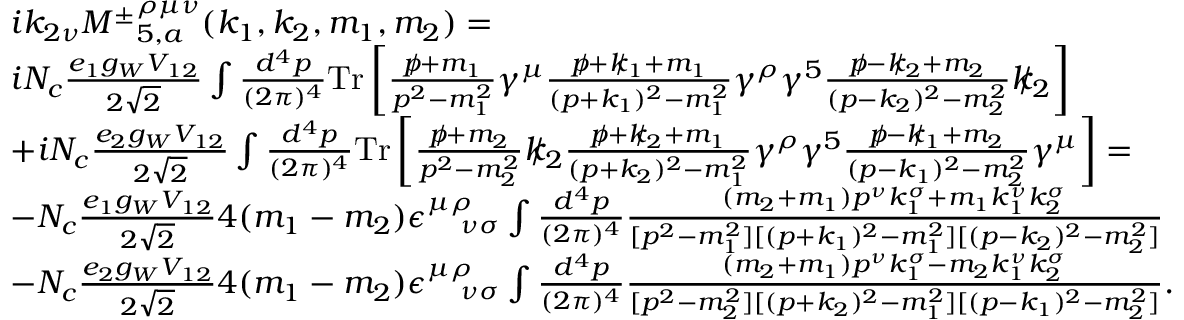Convert formula to latex. <formula><loc_0><loc_0><loc_500><loc_500>\begin{array} { r l } & { i k _ { 2 \nu } { M ^ { \pm } } _ { 5 , a } ^ { \rho \mu \nu } ( k _ { 1 } , k _ { 2 } , m _ { 1 } , m _ { 2 } ) = } \\ & { i N _ { c } \frac { e _ { 1 } g _ { W } V _ { 1 2 } } { 2 \sqrt { 2 } } \int \frac { d ^ { 4 } p } { ( 2 \pi ) ^ { 4 } } { T r } \left [ \frac { p \, / + m _ { 1 } } { p ^ { 2 } - m _ { 1 } ^ { 2 } } \gamma ^ { \mu } \frac { p \, / + k \, / _ { 1 } + m _ { 1 } } { ( p + k _ { 1 } ) ^ { 2 } - m _ { 1 } ^ { 2 } } \gamma ^ { \rho } \gamma ^ { 5 } \frac { p \, / - k \, / _ { 2 } + m _ { 2 } } { ( p - k _ { 2 } ) ^ { 2 } - m _ { 2 } ^ { 2 } } k \, / _ { 2 } \right ] } \\ & { + i N _ { c } \frac { e _ { 2 } g _ { W } V _ { 1 2 } } { 2 \sqrt { 2 } } \int \frac { d ^ { 4 } p } { ( 2 \pi ) ^ { 4 } } { T r } \left [ \frac { p \, / + m _ { 2 } } { p ^ { 2 } - m _ { 2 } ^ { 2 } } k \, / _ { 2 } \frac { p \, / + k \, / _ { 2 } + m _ { 1 } } { ( p + k _ { 2 } ) ^ { 2 } - m _ { 1 } ^ { 2 } } \gamma ^ { \rho } \gamma ^ { 5 } \frac { p \, / - k \, / _ { 1 } + m _ { 2 } } { ( p - k _ { 1 } ) ^ { 2 } - m _ { 2 } ^ { 2 } } \gamma ^ { \mu } \right ] = } \\ & { - N _ { c } \frac { e _ { 1 } g _ { W } V _ { 1 2 } } { 2 \sqrt { 2 } } 4 ( m _ { 1 } - m _ { 2 } ) \epsilon _ { \quad \nu \sigma } ^ { \mu \rho } \int \frac { d ^ { 4 } p } { ( 2 \pi ) ^ { 4 } } \frac { ( m _ { 2 } + m _ { 1 } ) p ^ { \nu } k _ { 1 } ^ { \sigma } + m _ { 1 } k _ { 1 } ^ { \nu } k _ { 2 } ^ { \sigma } } { [ p ^ { 2 } - m _ { 1 } ^ { 2 } ] [ ( p + k _ { 1 } ) ^ { 2 } - m _ { 1 } ^ { 2 } ] [ ( p - k _ { 2 } ) ^ { 2 } - m _ { 2 } ^ { 2 } ] } } \\ & { - N _ { c } \frac { e _ { 2 } g _ { W } V _ { 1 2 } } { 2 \sqrt { 2 } } 4 ( m _ { 1 } - m _ { 2 } ) \epsilon _ { \quad \nu \sigma } ^ { \mu \rho } \int \frac { d ^ { 4 } p } { ( 2 \pi ) ^ { 4 } } \frac { ( m _ { 2 } + m _ { 1 } ) p ^ { \nu } k _ { 1 } ^ { \sigma } - m _ { 2 } k _ { 1 } ^ { \nu } k _ { 2 } ^ { \sigma } } { [ p ^ { 2 } - m _ { 2 } ^ { 2 } ] [ ( p + k _ { 2 } ) ^ { 2 } - m _ { 1 } ^ { 2 } ] [ ( p - k _ { 1 } ) ^ { 2 } - m _ { 2 } ^ { 2 } ] } . } \end{array}</formula> 